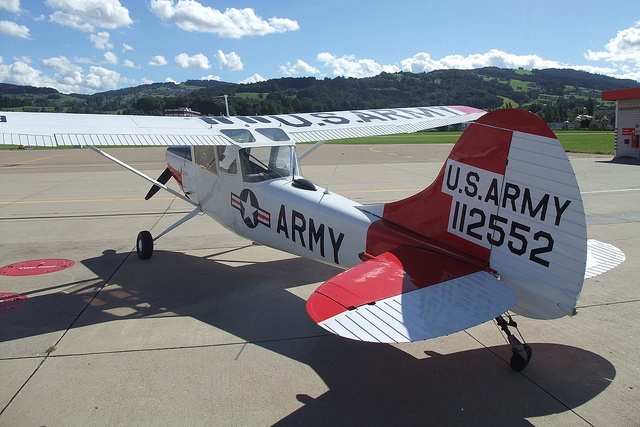Describe the objects in this image and their specific colors. I can see a airplane in lightblue, gray, lightgray, and black tones in this image. 